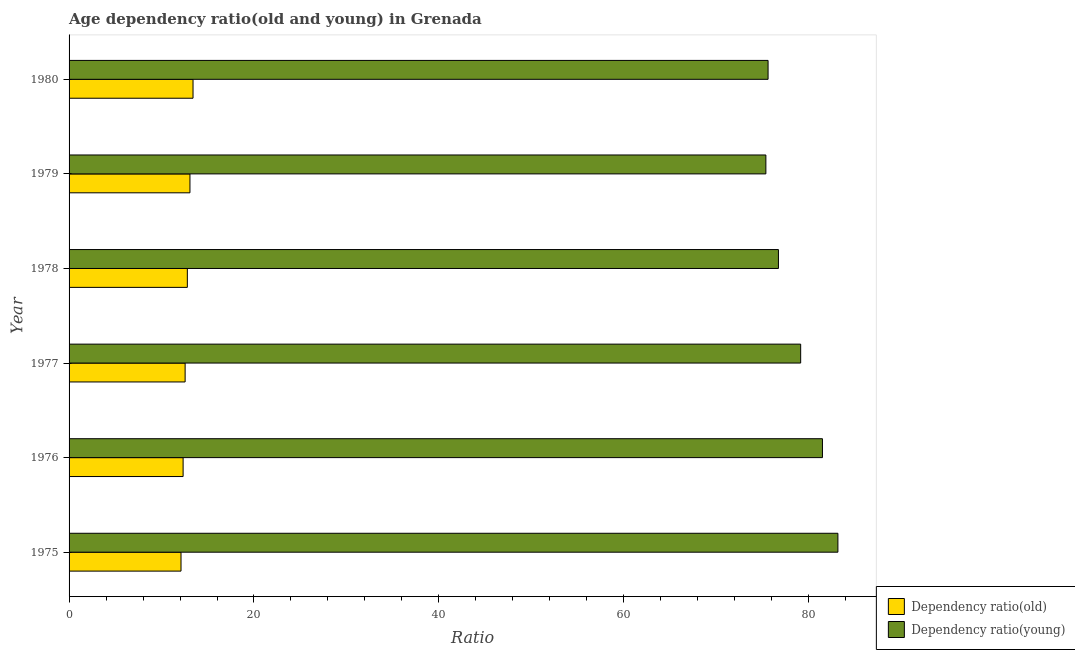How many groups of bars are there?
Offer a terse response. 6. How many bars are there on the 4th tick from the top?
Give a very brief answer. 2. How many bars are there on the 3rd tick from the bottom?
Your response must be concise. 2. What is the label of the 6th group of bars from the top?
Make the answer very short. 1975. In how many cases, is the number of bars for a given year not equal to the number of legend labels?
Your answer should be very brief. 0. What is the age dependency ratio(young) in 1976?
Provide a succinct answer. 81.48. Across all years, what is the maximum age dependency ratio(young)?
Provide a succinct answer. 83.15. Across all years, what is the minimum age dependency ratio(young)?
Make the answer very short. 75.36. In which year was the age dependency ratio(young) maximum?
Your answer should be compact. 1975. In which year was the age dependency ratio(young) minimum?
Provide a succinct answer. 1979. What is the total age dependency ratio(old) in the graph?
Your answer should be compact. 76.27. What is the difference between the age dependency ratio(old) in 1977 and that in 1980?
Ensure brevity in your answer.  -0.85. What is the difference between the age dependency ratio(old) in 1975 and the age dependency ratio(young) in 1977?
Provide a succinct answer. -67.02. What is the average age dependency ratio(young) per year?
Ensure brevity in your answer.  78.58. In the year 1975, what is the difference between the age dependency ratio(old) and age dependency ratio(young)?
Your response must be concise. -71.05. Is the difference between the age dependency ratio(old) in 1975 and 1977 greater than the difference between the age dependency ratio(young) in 1975 and 1977?
Give a very brief answer. No. What is the difference between the highest and the second highest age dependency ratio(old)?
Ensure brevity in your answer.  0.33. What is the difference between the highest and the lowest age dependency ratio(young)?
Give a very brief answer. 7.79. In how many years, is the age dependency ratio(old) greater than the average age dependency ratio(old) taken over all years?
Your answer should be compact. 3. Is the sum of the age dependency ratio(young) in 1977 and 1979 greater than the maximum age dependency ratio(old) across all years?
Your answer should be very brief. Yes. What does the 1st bar from the top in 1978 represents?
Keep it short and to the point. Dependency ratio(young). What does the 1st bar from the bottom in 1979 represents?
Provide a short and direct response. Dependency ratio(old). What is the difference between two consecutive major ticks on the X-axis?
Your answer should be very brief. 20. Are the values on the major ticks of X-axis written in scientific E-notation?
Your response must be concise. No. Does the graph contain any zero values?
Your answer should be very brief. No. Does the graph contain grids?
Offer a terse response. No. Where does the legend appear in the graph?
Offer a very short reply. Bottom right. How many legend labels are there?
Offer a terse response. 2. How are the legend labels stacked?
Provide a short and direct response. Vertical. What is the title of the graph?
Keep it short and to the point. Age dependency ratio(old and young) in Grenada. What is the label or title of the X-axis?
Keep it short and to the point. Ratio. What is the Ratio in Dependency ratio(old) in 1975?
Provide a succinct answer. 12.11. What is the Ratio of Dependency ratio(young) in 1975?
Provide a succinct answer. 83.15. What is the Ratio in Dependency ratio(old) in 1976?
Ensure brevity in your answer.  12.33. What is the Ratio of Dependency ratio(young) in 1976?
Offer a very short reply. 81.48. What is the Ratio of Dependency ratio(old) in 1977?
Offer a terse response. 12.55. What is the Ratio of Dependency ratio(young) in 1977?
Make the answer very short. 79.13. What is the Ratio in Dependency ratio(old) in 1978?
Your answer should be compact. 12.79. What is the Ratio in Dependency ratio(young) in 1978?
Make the answer very short. 76.72. What is the Ratio of Dependency ratio(old) in 1979?
Ensure brevity in your answer.  13.07. What is the Ratio of Dependency ratio(young) in 1979?
Provide a short and direct response. 75.36. What is the Ratio of Dependency ratio(old) in 1980?
Offer a terse response. 13.41. What is the Ratio in Dependency ratio(young) in 1980?
Your answer should be very brief. 75.6. Across all years, what is the maximum Ratio in Dependency ratio(old)?
Offer a terse response. 13.41. Across all years, what is the maximum Ratio in Dependency ratio(young)?
Give a very brief answer. 83.15. Across all years, what is the minimum Ratio in Dependency ratio(old)?
Provide a succinct answer. 12.11. Across all years, what is the minimum Ratio in Dependency ratio(young)?
Keep it short and to the point. 75.36. What is the total Ratio of Dependency ratio(old) in the graph?
Your answer should be compact. 76.27. What is the total Ratio in Dependency ratio(young) in the graph?
Your answer should be compact. 471.45. What is the difference between the Ratio in Dependency ratio(old) in 1975 and that in 1976?
Your answer should be compact. -0.23. What is the difference between the Ratio of Dependency ratio(young) in 1975 and that in 1976?
Make the answer very short. 1.67. What is the difference between the Ratio of Dependency ratio(old) in 1975 and that in 1977?
Keep it short and to the point. -0.44. What is the difference between the Ratio of Dependency ratio(young) in 1975 and that in 1977?
Make the answer very short. 4.03. What is the difference between the Ratio of Dependency ratio(old) in 1975 and that in 1978?
Your answer should be very brief. -0.68. What is the difference between the Ratio in Dependency ratio(young) in 1975 and that in 1978?
Your answer should be compact. 6.43. What is the difference between the Ratio of Dependency ratio(old) in 1975 and that in 1979?
Your answer should be compact. -0.97. What is the difference between the Ratio of Dependency ratio(young) in 1975 and that in 1979?
Give a very brief answer. 7.79. What is the difference between the Ratio of Dependency ratio(old) in 1975 and that in 1980?
Ensure brevity in your answer.  -1.3. What is the difference between the Ratio in Dependency ratio(young) in 1975 and that in 1980?
Offer a very short reply. 7.55. What is the difference between the Ratio in Dependency ratio(old) in 1976 and that in 1977?
Keep it short and to the point. -0.22. What is the difference between the Ratio of Dependency ratio(young) in 1976 and that in 1977?
Provide a succinct answer. 2.36. What is the difference between the Ratio of Dependency ratio(old) in 1976 and that in 1978?
Provide a succinct answer. -0.46. What is the difference between the Ratio of Dependency ratio(young) in 1976 and that in 1978?
Your answer should be compact. 4.76. What is the difference between the Ratio in Dependency ratio(old) in 1976 and that in 1979?
Your answer should be compact. -0.74. What is the difference between the Ratio of Dependency ratio(young) in 1976 and that in 1979?
Ensure brevity in your answer.  6.12. What is the difference between the Ratio in Dependency ratio(old) in 1976 and that in 1980?
Offer a very short reply. -1.07. What is the difference between the Ratio in Dependency ratio(young) in 1976 and that in 1980?
Your answer should be compact. 5.88. What is the difference between the Ratio in Dependency ratio(old) in 1977 and that in 1978?
Make the answer very short. -0.24. What is the difference between the Ratio of Dependency ratio(young) in 1977 and that in 1978?
Your answer should be very brief. 2.4. What is the difference between the Ratio of Dependency ratio(old) in 1977 and that in 1979?
Keep it short and to the point. -0.52. What is the difference between the Ratio of Dependency ratio(young) in 1977 and that in 1979?
Provide a succinct answer. 3.76. What is the difference between the Ratio of Dependency ratio(old) in 1977 and that in 1980?
Provide a short and direct response. -0.85. What is the difference between the Ratio of Dependency ratio(young) in 1977 and that in 1980?
Your answer should be compact. 3.52. What is the difference between the Ratio of Dependency ratio(old) in 1978 and that in 1979?
Your answer should be compact. -0.28. What is the difference between the Ratio of Dependency ratio(young) in 1978 and that in 1979?
Keep it short and to the point. 1.36. What is the difference between the Ratio in Dependency ratio(old) in 1978 and that in 1980?
Provide a succinct answer. -0.61. What is the difference between the Ratio in Dependency ratio(young) in 1978 and that in 1980?
Give a very brief answer. 1.12. What is the difference between the Ratio in Dependency ratio(old) in 1979 and that in 1980?
Your answer should be very brief. -0.33. What is the difference between the Ratio in Dependency ratio(young) in 1979 and that in 1980?
Provide a short and direct response. -0.24. What is the difference between the Ratio in Dependency ratio(old) in 1975 and the Ratio in Dependency ratio(young) in 1976?
Offer a terse response. -69.37. What is the difference between the Ratio of Dependency ratio(old) in 1975 and the Ratio of Dependency ratio(young) in 1977?
Ensure brevity in your answer.  -67.02. What is the difference between the Ratio of Dependency ratio(old) in 1975 and the Ratio of Dependency ratio(young) in 1978?
Provide a short and direct response. -64.61. What is the difference between the Ratio of Dependency ratio(old) in 1975 and the Ratio of Dependency ratio(young) in 1979?
Give a very brief answer. -63.26. What is the difference between the Ratio of Dependency ratio(old) in 1975 and the Ratio of Dependency ratio(young) in 1980?
Provide a succinct answer. -63.49. What is the difference between the Ratio in Dependency ratio(old) in 1976 and the Ratio in Dependency ratio(young) in 1977?
Keep it short and to the point. -66.79. What is the difference between the Ratio of Dependency ratio(old) in 1976 and the Ratio of Dependency ratio(young) in 1978?
Provide a short and direct response. -64.39. What is the difference between the Ratio of Dependency ratio(old) in 1976 and the Ratio of Dependency ratio(young) in 1979?
Keep it short and to the point. -63.03. What is the difference between the Ratio of Dependency ratio(old) in 1976 and the Ratio of Dependency ratio(young) in 1980?
Your answer should be very brief. -63.27. What is the difference between the Ratio of Dependency ratio(old) in 1977 and the Ratio of Dependency ratio(young) in 1978?
Make the answer very short. -64.17. What is the difference between the Ratio of Dependency ratio(old) in 1977 and the Ratio of Dependency ratio(young) in 1979?
Ensure brevity in your answer.  -62.81. What is the difference between the Ratio in Dependency ratio(old) in 1977 and the Ratio in Dependency ratio(young) in 1980?
Your answer should be very brief. -63.05. What is the difference between the Ratio in Dependency ratio(old) in 1978 and the Ratio in Dependency ratio(young) in 1979?
Provide a short and direct response. -62.57. What is the difference between the Ratio in Dependency ratio(old) in 1978 and the Ratio in Dependency ratio(young) in 1980?
Give a very brief answer. -62.81. What is the difference between the Ratio in Dependency ratio(old) in 1979 and the Ratio in Dependency ratio(young) in 1980?
Offer a very short reply. -62.53. What is the average Ratio in Dependency ratio(old) per year?
Offer a very short reply. 12.71. What is the average Ratio in Dependency ratio(young) per year?
Your answer should be very brief. 78.58. In the year 1975, what is the difference between the Ratio in Dependency ratio(old) and Ratio in Dependency ratio(young)?
Your answer should be very brief. -71.05. In the year 1976, what is the difference between the Ratio in Dependency ratio(old) and Ratio in Dependency ratio(young)?
Offer a terse response. -69.15. In the year 1977, what is the difference between the Ratio of Dependency ratio(old) and Ratio of Dependency ratio(young)?
Give a very brief answer. -66.57. In the year 1978, what is the difference between the Ratio of Dependency ratio(old) and Ratio of Dependency ratio(young)?
Provide a short and direct response. -63.93. In the year 1979, what is the difference between the Ratio in Dependency ratio(old) and Ratio in Dependency ratio(young)?
Offer a terse response. -62.29. In the year 1980, what is the difference between the Ratio in Dependency ratio(old) and Ratio in Dependency ratio(young)?
Your answer should be compact. -62.2. What is the ratio of the Ratio of Dependency ratio(old) in 1975 to that in 1976?
Keep it short and to the point. 0.98. What is the ratio of the Ratio in Dependency ratio(young) in 1975 to that in 1976?
Provide a short and direct response. 1.02. What is the ratio of the Ratio in Dependency ratio(old) in 1975 to that in 1977?
Offer a very short reply. 0.96. What is the ratio of the Ratio of Dependency ratio(young) in 1975 to that in 1977?
Your response must be concise. 1.05. What is the ratio of the Ratio in Dependency ratio(old) in 1975 to that in 1978?
Your answer should be compact. 0.95. What is the ratio of the Ratio of Dependency ratio(young) in 1975 to that in 1978?
Keep it short and to the point. 1.08. What is the ratio of the Ratio of Dependency ratio(old) in 1975 to that in 1979?
Your answer should be very brief. 0.93. What is the ratio of the Ratio of Dependency ratio(young) in 1975 to that in 1979?
Offer a very short reply. 1.1. What is the ratio of the Ratio of Dependency ratio(old) in 1975 to that in 1980?
Your response must be concise. 0.9. What is the ratio of the Ratio of Dependency ratio(young) in 1975 to that in 1980?
Provide a short and direct response. 1.1. What is the ratio of the Ratio of Dependency ratio(old) in 1976 to that in 1977?
Provide a succinct answer. 0.98. What is the ratio of the Ratio of Dependency ratio(young) in 1976 to that in 1977?
Keep it short and to the point. 1.03. What is the ratio of the Ratio of Dependency ratio(old) in 1976 to that in 1978?
Offer a very short reply. 0.96. What is the ratio of the Ratio of Dependency ratio(young) in 1976 to that in 1978?
Make the answer very short. 1.06. What is the ratio of the Ratio in Dependency ratio(old) in 1976 to that in 1979?
Ensure brevity in your answer.  0.94. What is the ratio of the Ratio of Dependency ratio(young) in 1976 to that in 1979?
Provide a succinct answer. 1.08. What is the ratio of the Ratio of Dependency ratio(old) in 1976 to that in 1980?
Your answer should be very brief. 0.92. What is the ratio of the Ratio in Dependency ratio(young) in 1976 to that in 1980?
Give a very brief answer. 1.08. What is the ratio of the Ratio of Dependency ratio(old) in 1977 to that in 1978?
Offer a very short reply. 0.98. What is the ratio of the Ratio in Dependency ratio(young) in 1977 to that in 1978?
Ensure brevity in your answer.  1.03. What is the ratio of the Ratio of Dependency ratio(old) in 1977 to that in 1979?
Offer a terse response. 0.96. What is the ratio of the Ratio in Dependency ratio(young) in 1977 to that in 1979?
Ensure brevity in your answer.  1.05. What is the ratio of the Ratio in Dependency ratio(old) in 1977 to that in 1980?
Ensure brevity in your answer.  0.94. What is the ratio of the Ratio in Dependency ratio(young) in 1977 to that in 1980?
Ensure brevity in your answer.  1.05. What is the ratio of the Ratio in Dependency ratio(old) in 1978 to that in 1979?
Your answer should be very brief. 0.98. What is the ratio of the Ratio of Dependency ratio(young) in 1978 to that in 1979?
Keep it short and to the point. 1.02. What is the ratio of the Ratio of Dependency ratio(old) in 1978 to that in 1980?
Make the answer very short. 0.95. What is the ratio of the Ratio in Dependency ratio(young) in 1978 to that in 1980?
Offer a terse response. 1.01. What is the ratio of the Ratio in Dependency ratio(old) in 1979 to that in 1980?
Keep it short and to the point. 0.98. What is the difference between the highest and the second highest Ratio in Dependency ratio(old)?
Keep it short and to the point. 0.33. What is the difference between the highest and the second highest Ratio of Dependency ratio(young)?
Your answer should be very brief. 1.67. What is the difference between the highest and the lowest Ratio in Dependency ratio(old)?
Your answer should be compact. 1.3. What is the difference between the highest and the lowest Ratio in Dependency ratio(young)?
Offer a terse response. 7.79. 